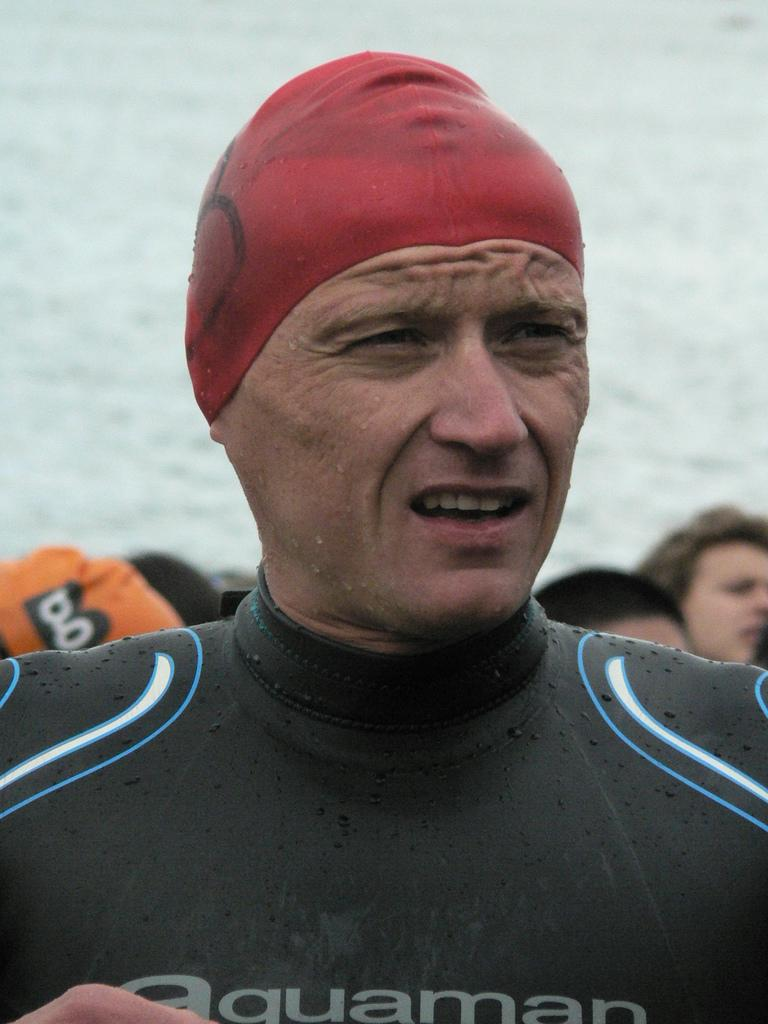What is the primary subject of the image? There is a person standing in the image. Can you describe the surrounding environment in the image? There are many people behind the standing person. What natural element is visible in the image? There is water visible in the image. What force is being applied to the water in the image? There is no force being applied to the water in the image; it is stationary. What type of wilderness can be seen in the image? There is no wilderness present in the image. 